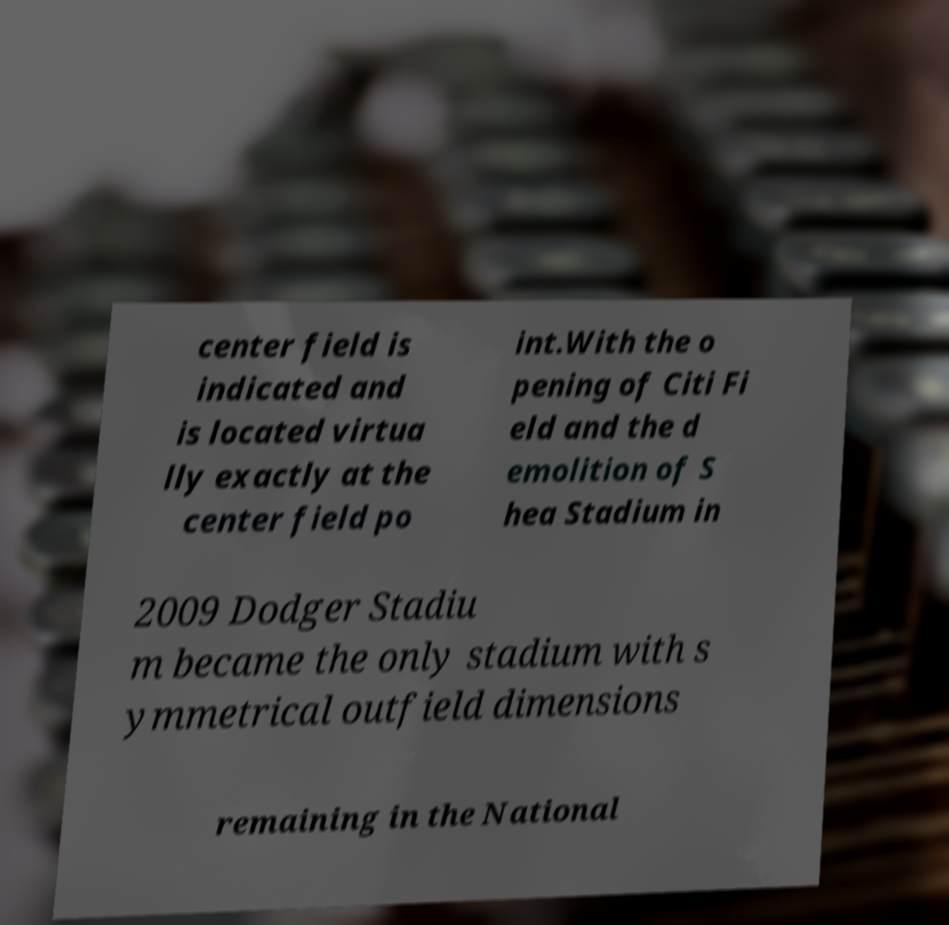Can you accurately transcribe the text from the provided image for me? center field is indicated and is located virtua lly exactly at the center field po int.With the o pening of Citi Fi eld and the d emolition of S hea Stadium in 2009 Dodger Stadiu m became the only stadium with s ymmetrical outfield dimensions remaining in the National 